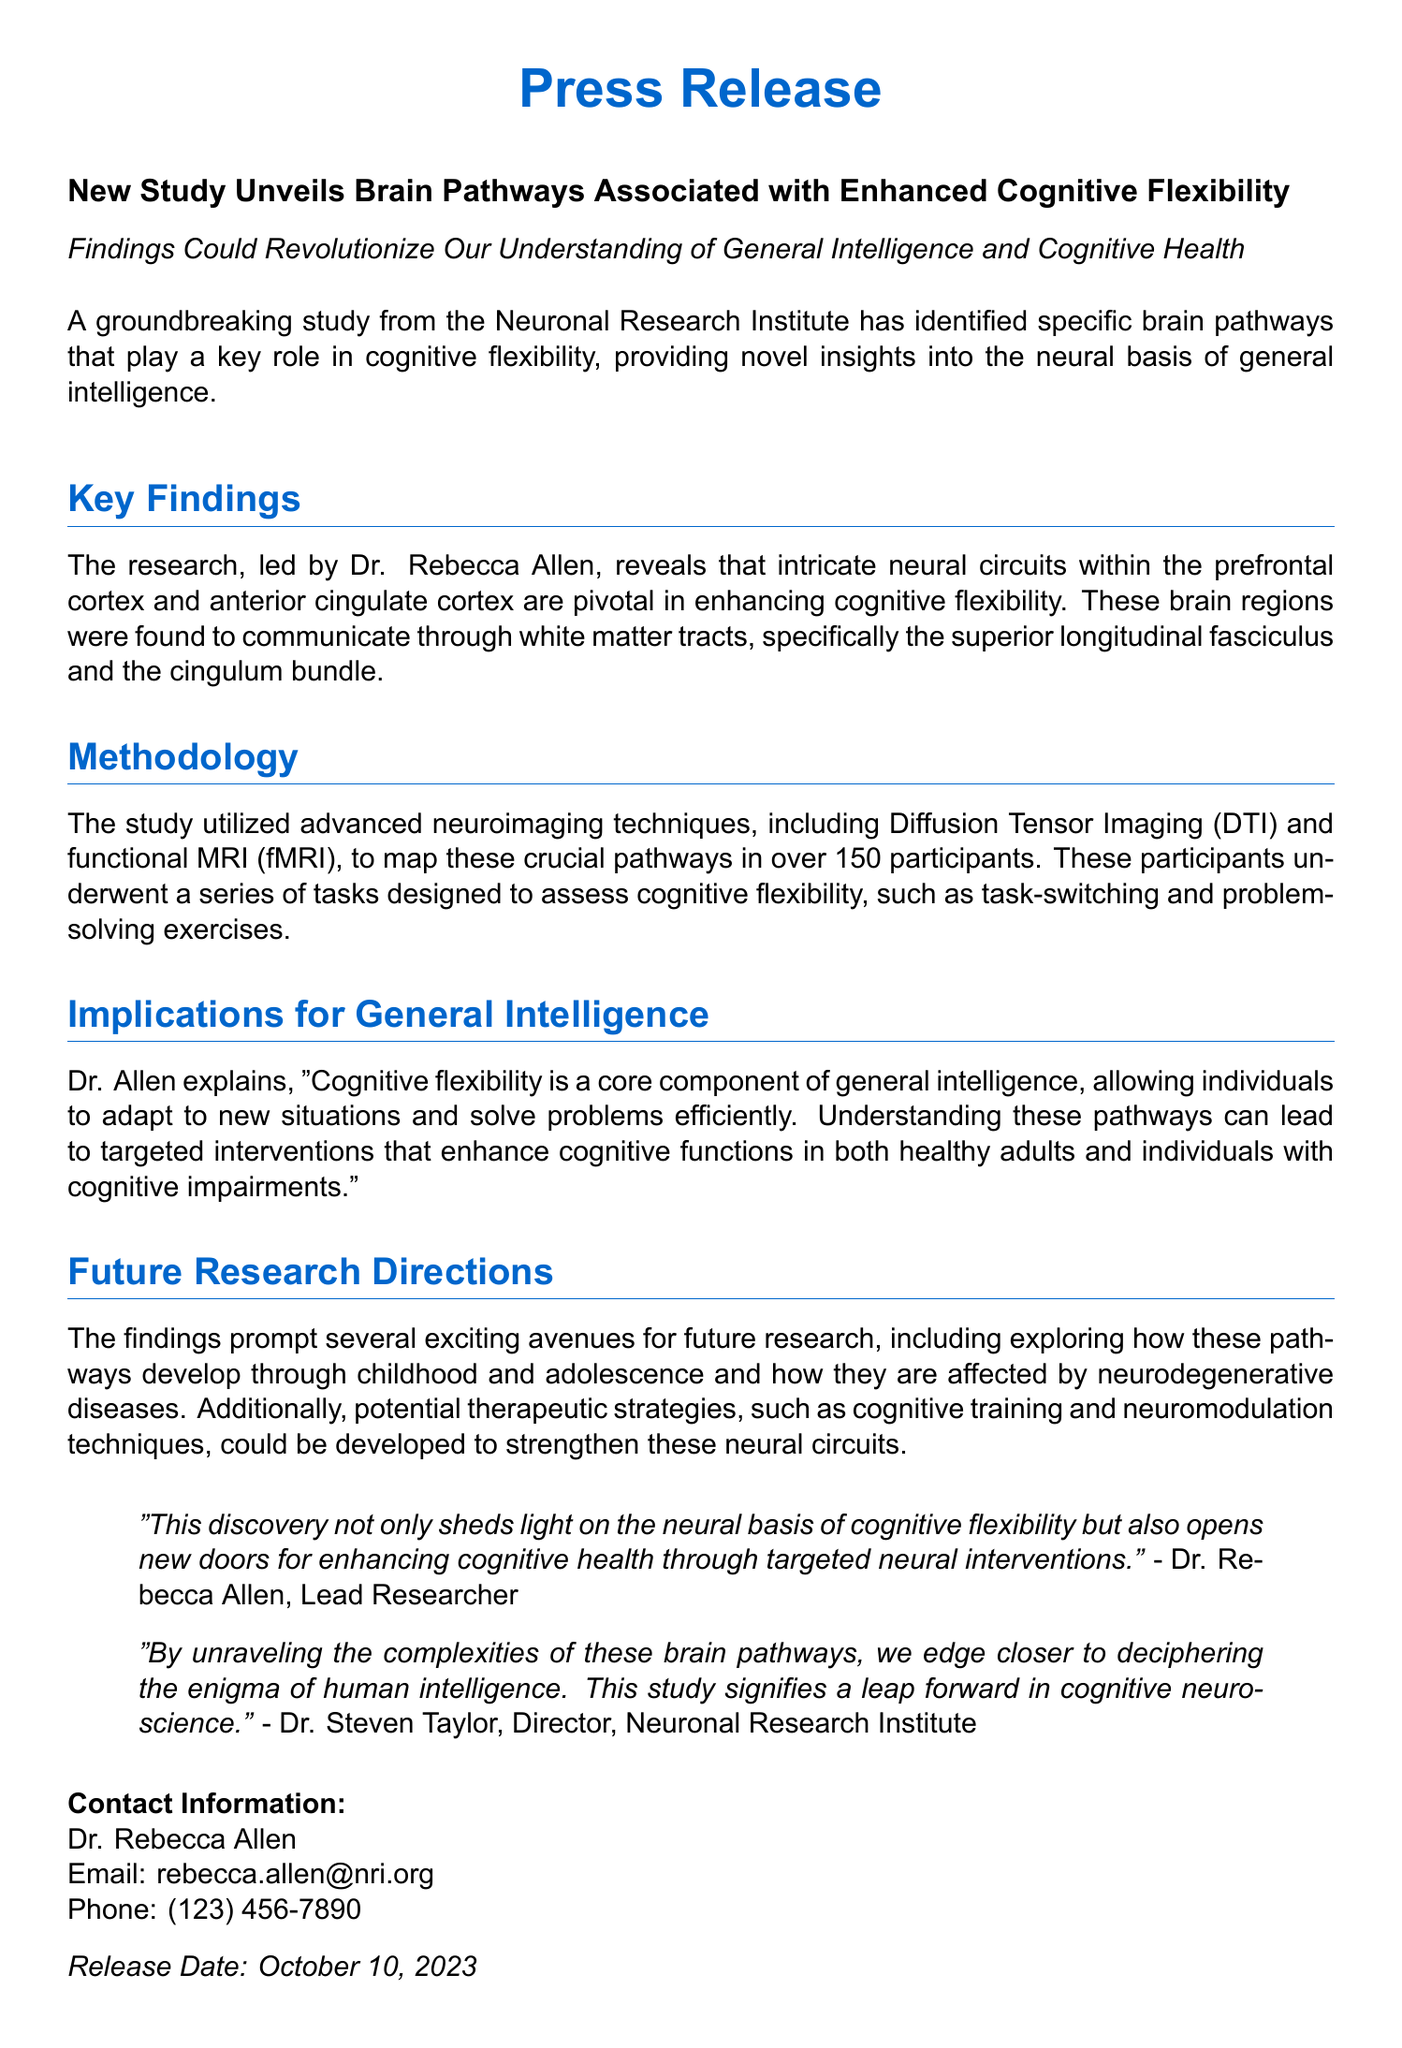What is the title of the study? The title is specifically stated in the document as "New Study Unveils Brain Pathways Associated with Enhanced Cognitive Flexibility."
Answer: New Study Unveils Brain Pathways Associated with Enhanced Cognitive Flexibility Who led the research? The document clearly states that Dr. Rebecca Allen led the research.
Answer: Dr. Rebecca Allen What techniques were used in the study? The study utilized advanced neuroimaging techniques, including Diffusion Tensor Imaging (DTI) and functional MRI (fMRI).
Answer: Diffusion Tensor Imaging (DTI) and functional MRI (fMRI) How many participants were involved in the study? The document mentions that over 150 participants were involved in the study.
Answer: over 150 participants What is cognitive flexibility considered a core component of? The document states that cognitive flexibility is considered a core component of general intelligence.
Answer: general intelligence What is one potential therapeutic strategy mentioned? The study mentions cognitive training as a potential therapeutic strategy.
Answer: cognitive training When was the press release dated? The release date is specifically indicated in the document as October 10, 2023.
Answer: October 10, 2023 How does Dr. Allen describe the importance of cognitive flexibility? Dr. Allen explains that cognitive flexibility allows individuals to adapt to new situations and solve problems efficiently.
Answer: adapt to new situations and solve problems efficiently What future research direction is suggested? The document suggests exploring how these pathways develop through childhood and adolescence as a future research direction.
Answer: exploring how these pathways develop through childhood and adolescence 